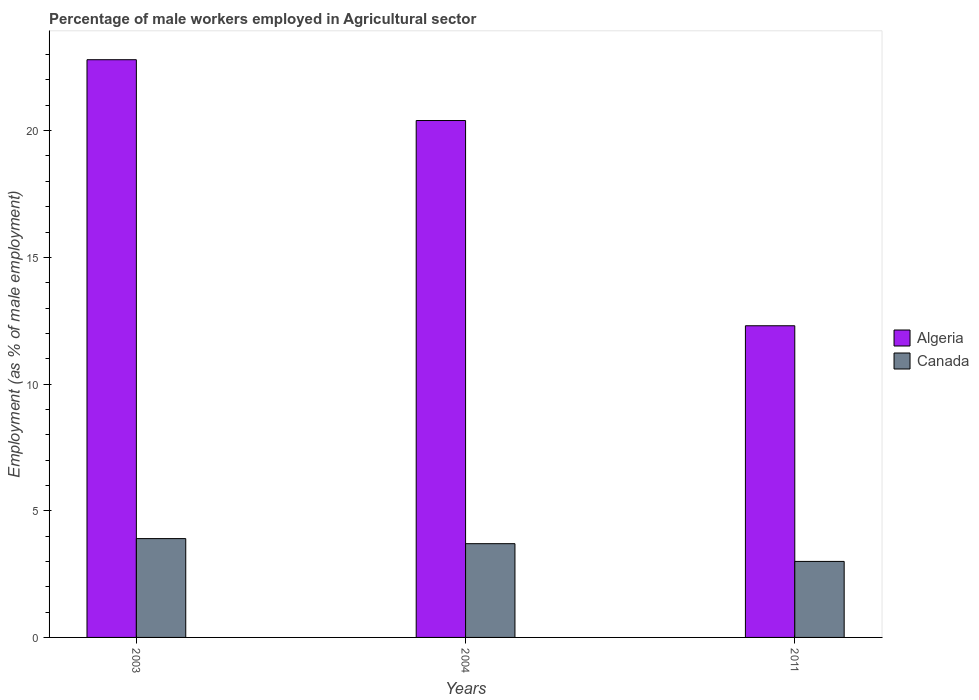How many different coloured bars are there?
Offer a terse response. 2. How many groups of bars are there?
Your response must be concise. 3. In how many cases, is the number of bars for a given year not equal to the number of legend labels?
Give a very brief answer. 0. What is the percentage of male workers employed in Agricultural sector in Canada in 2003?
Your answer should be compact. 3.9. Across all years, what is the maximum percentage of male workers employed in Agricultural sector in Algeria?
Offer a terse response. 22.8. Across all years, what is the minimum percentage of male workers employed in Agricultural sector in Algeria?
Ensure brevity in your answer.  12.3. In which year was the percentage of male workers employed in Agricultural sector in Canada maximum?
Give a very brief answer. 2003. In which year was the percentage of male workers employed in Agricultural sector in Algeria minimum?
Give a very brief answer. 2011. What is the total percentage of male workers employed in Agricultural sector in Algeria in the graph?
Provide a short and direct response. 55.5. What is the difference between the percentage of male workers employed in Agricultural sector in Canada in 2003 and that in 2011?
Make the answer very short. 0.9. What is the difference between the percentage of male workers employed in Agricultural sector in Canada in 2011 and the percentage of male workers employed in Agricultural sector in Algeria in 2004?
Your answer should be compact. -17.4. What is the average percentage of male workers employed in Agricultural sector in Algeria per year?
Your response must be concise. 18.5. In the year 2011, what is the difference between the percentage of male workers employed in Agricultural sector in Algeria and percentage of male workers employed in Agricultural sector in Canada?
Offer a terse response. 9.3. In how many years, is the percentage of male workers employed in Agricultural sector in Canada greater than 7 %?
Offer a terse response. 0. What is the ratio of the percentage of male workers employed in Agricultural sector in Algeria in 2003 to that in 2011?
Provide a succinct answer. 1.85. What is the difference between the highest and the second highest percentage of male workers employed in Agricultural sector in Algeria?
Offer a very short reply. 2.4. What is the difference between the highest and the lowest percentage of male workers employed in Agricultural sector in Algeria?
Provide a short and direct response. 10.5. What does the 1st bar from the left in 2011 represents?
Give a very brief answer. Algeria. What does the 2nd bar from the right in 2003 represents?
Provide a succinct answer. Algeria. How many bars are there?
Provide a short and direct response. 6. Are all the bars in the graph horizontal?
Provide a short and direct response. No. How many years are there in the graph?
Your answer should be compact. 3. Does the graph contain any zero values?
Keep it short and to the point. No. Does the graph contain grids?
Your answer should be compact. No. What is the title of the graph?
Provide a short and direct response. Percentage of male workers employed in Agricultural sector. Does "Peru" appear as one of the legend labels in the graph?
Offer a terse response. No. What is the label or title of the X-axis?
Offer a very short reply. Years. What is the label or title of the Y-axis?
Provide a succinct answer. Employment (as % of male employment). What is the Employment (as % of male employment) of Algeria in 2003?
Your answer should be compact. 22.8. What is the Employment (as % of male employment) of Canada in 2003?
Offer a terse response. 3.9. What is the Employment (as % of male employment) in Algeria in 2004?
Make the answer very short. 20.4. What is the Employment (as % of male employment) of Canada in 2004?
Keep it short and to the point. 3.7. What is the Employment (as % of male employment) in Algeria in 2011?
Provide a succinct answer. 12.3. What is the Employment (as % of male employment) of Canada in 2011?
Give a very brief answer. 3. Across all years, what is the maximum Employment (as % of male employment) in Algeria?
Your answer should be very brief. 22.8. Across all years, what is the maximum Employment (as % of male employment) in Canada?
Provide a short and direct response. 3.9. Across all years, what is the minimum Employment (as % of male employment) in Algeria?
Your answer should be compact. 12.3. What is the total Employment (as % of male employment) in Algeria in the graph?
Provide a short and direct response. 55.5. What is the total Employment (as % of male employment) of Canada in the graph?
Provide a short and direct response. 10.6. What is the difference between the Employment (as % of male employment) in Algeria in 2003 and that in 2004?
Ensure brevity in your answer.  2.4. What is the difference between the Employment (as % of male employment) of Canada in 2003 and that in 2004?
Provide a short and direct response. 0.2. What is the difference between the Employment (as % of male employment) of Algeria in 2004 and that in 2011?
Make the answer very short. 8.1. What is the difference between the Employment (as % of male employment) of Canada in 2004 and that in 2011?
Offer a very short reply. 0.7. What is the difference between the Employment (as % of male employment) in Algeria in 2003 and the Employment (as % of male employment) in Canada in 2011?
Offer a very short reply. 19.8. What is the average Employment (as % of male employment) of Algeria per year?
Your response must be concise. 18.5. What is the average Employment (as % of male employment) of Canada per year?
Provide a succinct answer. 3.53. In the year 2003, what is the difference between the Employment (as % of male employment) of Algeria and Employment (as % of male employment) of Canada?
Provide a succinct answer. 18.9. What is the ratio of the Employment (as % of male employment) in Algeria in 2003 to that in 2004?
Provide a succinct answer. 1.12. What is the ratio of the Employment (as % of male employment) of Canada in 2003 to that in 2004?
Your answer should be very brief. 1.05. What is the ratio of the Employment (as % of male employment) of Algeria in 2003 to that in 2011?
Give a very brief answer. 1.85. What is the ratio of the Employment (as % of male employment) of Algeria in 2004 to that in 2011?
Provide a short and direct response. 1.66. What is the ratio of the Employment (as % of male employment) of Canada in 2004 to that in 2011?
Offer a terse response. 1.23. What is the difference between the highest and the lowest Employment (as % of male employment) of Canada?
Your answer should be very brief. 0.9. 